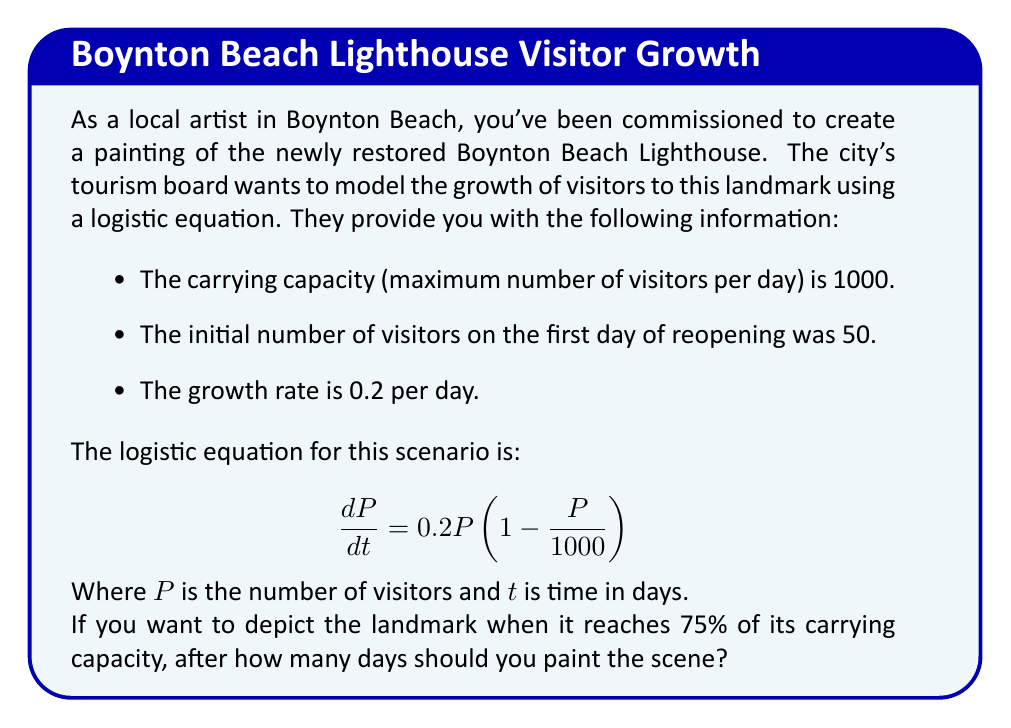Could you help me with this problem? To solve this problem, we need to use the solution to the logistic equation:

$$P(t) = \frac{K}{1 + (\frac{K}{P_0} - 1)e^{-rt}}$$

Where:
- $K$ is the carrying capacity (1000)
- $P_0$ is the initial population (50)
- $r$ is the growth rate (0.2)
- $t$ is time in days

We want to find $t$ when $P(t)$ is 75% of $K$, which is 750 visitors.

Step 1: Set up the equation
$$750 = \frac{1000}{1 + (\frac{1000}{50} - 1)e^{-0.2t}}$$

Step 2: Simplify
$$750 = \frac{1000}{1 + 19e^{-0.2t}}$$

Step 3: Solve for $e^{-0.2t}$
$$\frac{750}{1000} = \frac{1}{1 + 19e^{-0.2t}}$$
$$\frac{3}{4} = \frac{1}{1 + 19e^{-0.2t}}$$
$$1 + 19e^{-0.2t} = \frac{4}{3}$$
$$19e^{-0.2t} = \frac{1}{3}$$
$$e^{-0.2t} = \frac{1}{57}$$

Step 4: Take natural log of both sides
$$-0.2t = \ln(\frac{1}{57})$$

Step 5: Solve for $t$
$$t = \frac{-\ln(\frac{1}{57})}{0.2} = \frac{\ln(57)}{0.2} \approx 20.27$$

Therefore, it will take approximately 20.27 days for the number of visitors to reach 75% of the carrying capacity.
Answer: 20.27 days 